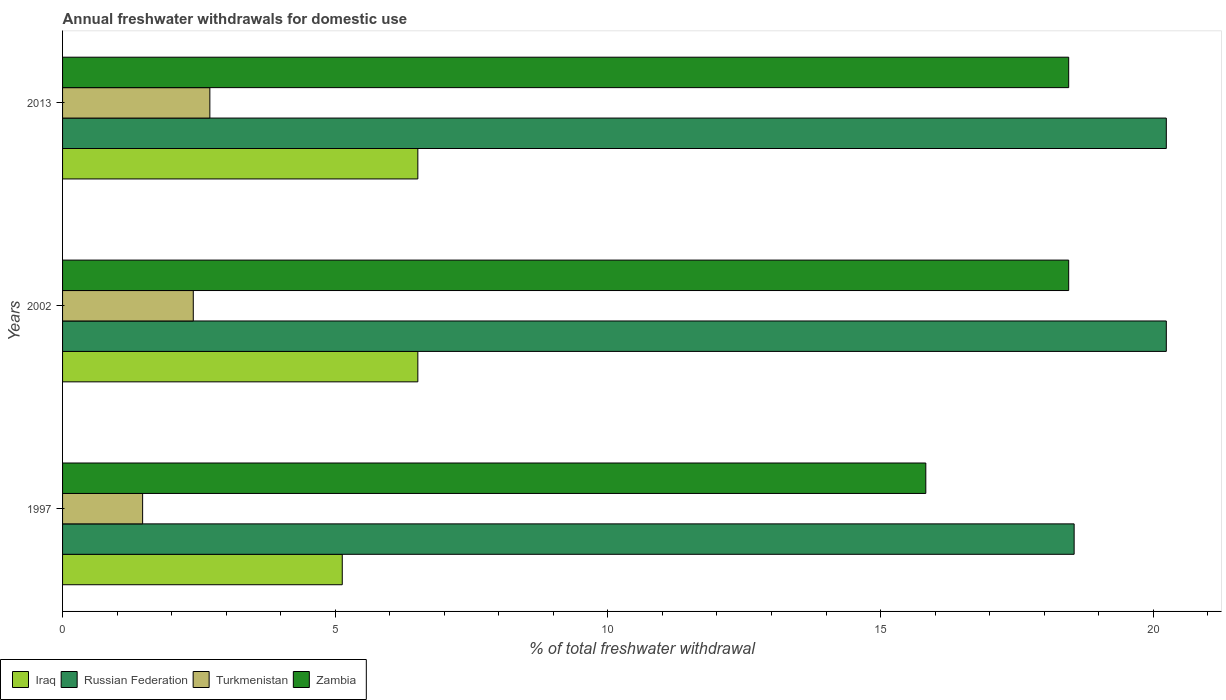How many groups of bars are there?
Keep it short and to the point. 3. Are the number of bars on each tick of the Y-axis equal?
Keep it short and to the point. Yes. How many bars are there on the 3rd tick from the top?
Ensure brevity in your answer.  4. What is the total annual withdrawals from freshwater in Russian Federation in 2002?
Provide a succinct answer. 20.24. Across all years, what is the maximum total annual withdrawals from freshwater in Russian Federation?
Provide a short and direct response. 20.24. Across all years, what is the minimum total annual withdrawals from freshwater in Russian Federation?
Your response must be concise. 18.55. What is the total total annual withdrawals from freshwater in Russian Federation in the graph?
Your response must be concise. 59.03. What is the difference between the total annual withdrawals from freshwater in Russian Federation in 1997 and that in 2013?
Give a very brief answer. -1.69. What is the difference between the total annual withdrawals from freshwater in Iraq in 2013 and the total annual withdrawals from freshwater in Russian Federation in 2002?
Give a very brief answer. -13.72. What is the average total annual withdrawals from freshwater in Iraq per year?
Give a very brief answer. 6.05. In the year 1997, what is the difference between the total annual withdrawals from freshwater in Zambia and total annual withdrawals from freshwater in Russian Federation?
Give a very brief answer. -2.72. In how many years, is the total annual withdrawals from freshwater in Zambia greater than 15 %?
Offer a terse response. 3. What is the ratio of the total annual withdrawals from freshwater in Turkmenistan in 1997 to that in 2013?
Provide a succinct answer. 0.54. Is the total annual withdrawals from freshwater in Zambia in 2002 less than that in 2013?
Your response must be concise. No. Is the difference between the total annual withdrawals from freshwater in Zambia in 1997 and 2002 greater than the difference between the total annual withdrawals from freshwater in Russian Federation in 1997 and 2002?
Your answer should be very brief. No. What is the difference between the highest and the second highest total annual withdrawals from freshwater in Iraq?
Offer a very short reply. 0. What is the difference between the highest and the lowest total annual withdrawals from freshwater in Turkmenistan?
Keep it short and to the point. 1.23. In how many years, is the total annual withdrawals from freshwater in Russian Federation greater than the average total annual withdrawals from freshwater in Russian Federation taken over all years?
Make the answer very short. 2. Is it the case that in every year, the sum of the total annual withdrawals from freshwater in Iraq and total annual withdrawals from freshwater in Turkmenistan is greater than the sum of total annual withdrawals from freshwater in Zambia and total annual withdrawals from freshwater in Russian Federation?
Make the answer very short. No. What does the 3rd bar from the top in 2002 represents?
Ensure brevity in your answer.  Russian Federation. What does the 2nd bar from the bottom in 2002 represents?
Make the answer very short. Russian Federation. What is the difference between two consecutive major ticks on the X-axis?
Your response must be concise. 5. Are the values on the major ticks of X-axis written in scientific E-notation?
Offer a terse response. No. Does the graph contain grids?
Ensure brevity in your answer.  No. Where does the legend appear in the graph?
Offer a very short reply. Bottom left. How are the legend labels stacked?
Ensure brevity in your answer.  Horizontal. What is the title of the graph?
Offer a terse response. Annual freshwater withdrawals for domestic use. What is the label or title of the X-axis?
Your answer should be compact. % of total freshwater withdrawal. What is the label or title of the Y-axis?
Offer a terse response. Years. What is the % of total freshwater withdrawal of Iraq in 1997?
Your answer should be compact. 5.13. What is the % of total freshwater withdrawal of Russian Federation in 1997?
Make the answer very short. 18.55. What is the % of total freshwater withdrawal in Turkmenistan in 1997?
Give a very brief answer. 1.47. What is the % of total freshwater withdrawal in Zambia in 1997?
Your answer should be very brief. 15.83. What is the % of total freshwater withdrawal of Iraq in 2002?
Provide a succinct answer. 6.51. What is the % of total freshwater withdrawal in Russian Federation in 2002?
Offer a very short reply. 20.24. What is the % of total freshwater withdrawal in Turkmenistan in 2002?
Offer a very short reply. 2.4. What is the % of total freshwater withdrawal of Zambia in 2002?
Offer a very short reply. 18.45. What is the % of total freshwater withdrawal in Iraq in 2013?
Offer a very short reply. 6.51. What is the % of total freshwater withdrawal of Russian Federation in 2013?
Give a very brief answer. 20.24. What is the % of total freshwater withdrawal in Turkmenistan in 2013?
Keep it short and to the point. 2.7. What is the % of total freshwater withdrawal in Zambia in 2013?
Your answer should be very brief. 18.45. Across all years, what is the maximum % of total freshwater withdrawal of Iraq?
Keep it short and to the point. 6.51. Across all years, what is the maximum % of total freshwater withdrawal in Russian Federation?
Your answer should be compact. 20.24. Across all years, what is the maximum % of total freshwater withdrawal of Turkmenistan?
Your response must be concise. 2.7. Across all years, what is the maximum % of total freshwater withdrawal in Zambia?
Your answer should be compact. 18.45. Across all years, what is the minimum % of total freshwater withdrawal of Iraq?
Give a very brief answer. 5.13. Across all years, what is the minimum % of total freshwater withdrawal of Russian Federation?
Provide a succinct answer. 18.55. Across all years, what is the minimum % of total freshwater withdrawal in Turkmenistan?
Ensure brevity in your answer.  1.47. Across all years, what is the minimum % of total freshwater withdrawal of Zambia?
Offer a very short reply. 15.83. What is the total % of total freshwater withdrawal in Iraq in the graph?
Offer a terse response. 18.16. What is the total % of total freshwater withdrawal of Russian Federation in the graph?
Your answer should be very brief. 59.03. What is the total % of total freshwater withdrawal in Turkmenistan in the graph?
Make the answer very short. 6.57. What is the total % of total freshwater withdrawal in Zambia in the graph?
Provide a succinct answer. 52.73. What is the difference between the % of total freshwater withdrawal of Iraq in 1997 and that in 2002?
Your response must be concise. -1.39. What is the difference between the % of total freshwater withdrawal of Russian Federation in 1997 and that in 2002?
Provide a short and direct response. -1.69. What is the difference between the % of total freshwater withdrawal in Turkmenistan in 1997 and that in 2002?
Give a very brief answer. -0.93. What is the difference between the % of total freshwater withdrawal in Zambia in 1997 and that in 2002?
Offer a terse response. -2.62. What is the difference between the % of total freshwater withdrawal in Iraq in 1997 and that in 2013?
Ensure brevity in your answer.  -1.39. What is the difference between the % of total freshwater withdrawal in Russian Federation in 1997 and that in 2013?
Offer a very short reply. -1.69. What is the difference between the % of total freshwater withdrawal of Turkmenistan in 1997 and that in 2013?
Your response must be concise. -1.23. What is the difference between the % of total freshwater withdrawal of Zambia in 1997 and that in 2013?
Your response must be concise. -2.62. What is the difference between the % of total freshwater withdrawal of Turkmenistan in 2002 and that in 2013?
Offer a terse response. -0.3. What is the difference between the % of total freshwater withdrawal in Zambia in 2002 and that in 2013?
Ensure brevity in your answer.  0. What is the difference between the % of total freshwater withdrawal in Iraq in 1997 and the % of total freshwater withdrawal in Russian Federation in 2002?
Offer a terse response. -15.11. What is the difference between the % of total freshwater withdrawal of Iraq in 1997 and the % of total freshwater withdrawal of Turkmenistan in 2002?
Keep it short and to the point. 2.73. What is the difference between the % of total freshwater withdrawal of Iraq in 1997 and the % of total freshwater withdrawal of Zambia in 2002?
Offer a terse response. -13.32. What is the difference between the % of total freshwater withdrawal in Russian Federation in 1997 and the % of total freshwater withdrawal in Turkmenistan in 2002?
Provide a short and direct response. 16.15. What is the difference between the % of total freshwater withdrawal of Turkmenistan in 1997 and the % of total freshwater withdrawal of Zambia in 2002?
Offer a very short reply. -16.98. What is the difference between the % of total freshwater withdrawal in Iraq in 1997 and the % of total freshwater withdrawal in Russian Federation in 2013?
Your response must be concise. -15.11. What is the difference between the % of total freshwater withdrawal of Iraq in 1997 and the % of total freshwater withdrawal of Turkmenistan in 2013?
Ensure brevity in your answer.  2.43. What is the difference between the % of total freshwater withdrawal of Iraq in 1997 and the % of total freshwater withdrawal of Zambia in 2013?
Your answer should be compact. -13.32. What is the difference between the % of total freshwater withdrawal of Russian Federation in 1997 and the % of total freshwater withdrawal of Turkmenistan in 2013?
Your answer should be compact. 15.85. What is the difference between the % of total freshwater withdrawal of Russian Federation in 1997 and the % of total freshwater withdrawal of Zambia in 2013?
Keep it short and to the point. 0.1. What is the difference between the % of total freshwater withdrawal in Turkmenistan in 1997 and the % of total freshwater withdrawal in Zambia in 2013?
Your answer should be very brief. -16.98. What is the difference between the % of total freshwater withdrawal of Iraq in 2002 and the % of total freshwater withdrawal of Russian Federation in 2013?
Give a very brief answer. -13.72. What is the difference between the % of total freshwater withdrawal in Iraq in 2002 and the % of total freshwater withdrawal in Turkmenistan in 2013?
Your answer should be compact. 3.81. What is the difference between the % of total freshwater withdrawal of Iraq in 2002 and the % of total freshwater withdrawal of Zambia in 2013?
Ensure brevity in your answer.  -11.94. What is the difference between the % of total freshwater withdrawal of Russian Federation in 2002 and the % of total freshwater withdrawal of Turkmenistan in 2013?
Ensure brevity in your answer.  17.54. What is the difference between the % of total freshwater withdrawal of Russian Federation in 2002 and the % of total freshwater withdrawal of Zambia in 2013?
Give a very brief answer. 1.79. What is the difference between the % of total freshwater withdrawal of Turkmenistan in 2002 and the % of total freshwater withdrawal of Zambia in 2013?
Offer a terse response. -16.05. What is the average % of total freshwater withdrawal of Iraq per year?
Provide a succinct answer. 6.05. What is the average % of total freshwater withdrawal in Russian Federation per year?
Your answer should be compact. 19.68. What is the average % of total freshwater withdrawal in Turkmenistan per year?
Provide a succinct answer. 2.19. What is the average % of total freshwater withdrawal of Zambia per year?
Ensure brevity in your answer.  17.58. In the year 1997, what is the difference between the % of total freshwater withdrawal of Iraq and % of total freshwater withdrawal of Russian Federation?
Your answer should be compact. -13.42. In the year 1997, what is the difference between the % of total freshwater withdrawal of Iraq and % of total freshwater withdrawal of Turkmenistan?
Provide a short and direct response. 3.66. In the year 1997, what is the difference between the % of total freshwater withdrawal of Iraq and % of total freshwater withdrawal of Zambia?
Your response must be concise. -10.7. In the year 1997, what is the difference between the % of total freshwater withdrawal of Russian Federation and % of total freshwater withdrawal of Turkmenistan?
Keep it short and to the point. 17.08. In the year 1997, what is the difference between the % of total freshwater withdrawal of Russian Federation and % of total freshwater withdrawal of Zambia?
Offer a terse response. 2.72. In the year 1997, what is the difference between the % of total freshwater withdrawal in Turkmenistan and % of total freshwater withdrawal in Zambia?
Your answer should be very brief. -14.36. In the year 2002, what is the difference between the % of total freshwater withdrawal of Iraq and % of total freshwater withdrawal of Russian Federation?
Provide a succinct answer. -13.72. In the year 2002, what is the difference between the % of total freshwater withdrawal in Iraq and % of total freshwater withdrawal in Turkmenistan?
Give a very brief answer. 4.12. In the year 2002, what is the difference between the % of total freshwater withdrawal in Iraq and % of total freshwater withdrawal in Zambia?
Ensure brevity in your answer.  -11.94. In the year 2002, what is the difference between the % of total freshwater withdrawal of Russian Federation and % of total freshwater withdrawal of Turkmenistan?
Offer a terse response. 17.84. In the year 2002, what is the difference between the % of total freshwater withdrawal in Russian Federation and % of total freshwater withdrawal in Zambia?
Give a very brief answer. 1.79. In the year 2002, what is the difference between the % of total freshwater withdrawal in Turkmenistan and % of total freshwater withdrawal in Zambia?
Your answer should be very brief. -16.05. In the year 2013, what is the difference between the % of total freshwater withdrawal of Iraq and % of total freshwater withdrawal of Russian Federation?
Offer a terse response. -13.72. In the year 2013, what is the difference between the % of total freshwater withdrawal of Iraq and % of total freshwater withdrawal of Turkmenistan?
Keep it short and to the point. 3.81. In the year 2013, what is the difference between the % of total freshwater withdrawal in Iraq and % of total freshwater withdrawal in Zambia?
Offer a very short reply. -11.94. In the year 2013, what is the difference between the % of total freshwater withdrawal in Russian Federation and % of total freshwater withdrawal in Turkmenistan?
Your response must be concise. 17.54. In the year 2013, what is the difference between the % of total freshwater withdrawal in Russian Federation and % of total freshwater withdrawal in Zambia?
Provide a succinct answer. 1.79. In the year 2013, what is the difference between the % of total freshwater withdrawal in Turkmenistan and % of total freshwater withdrawal in Zambia?
Make the answer very short. -15.75. What is the ratio of the % of total freshwater withdrawal in Iraq in 1997 to that in 2002?
Give a very brief answer. 0.79. What is the ratio of the % of total freshwater withdrawal of Russian Federation in 1997 to that in 2002?
Provide a succinct answer. 0.92. What is the ratio of the % of total freshwater withdrawal in Turkmenistan in 1997 to that in 2002?
Provide a short and direct response. 0.61. What is the ratio of the % of total freshwater withdrawal of Zambia in 1997 to that in 2002?
Keep it short and to the point. 0.86. What is the ratio of the % of total freshwater withdrawal in Iraq in 1997 to that in 2013?
Offer a very short reply. 0.79. What is the ratio of the % of total freshwater withdrawal of Russian Federation in 1997 to that in 2013?
Your response must be concise. 0.92. What is the ratio of the % of total freshwater withdrawal of Turkmenistan in 1997 to that in 2013?
Offer a terse response. 0.54. What is the ratio of the % of total freshwater withdrawal in Zambia in 1997 to that in 2013?
Your answer should be compact. 0.86. What is the ratio of the % of total freshwater withdrawal in Turkmenistan in 2002 to that in 2013?
Your answer should be very brief. 0.89. What is the difference between the highest and the second highest % of total freshwater withdrawal in Turkmenistan?
Give a very brief answer. 0.3. What is the difference between the highest and the second highest % of total freshwater withdrawal in Zambia?
Provide a short and direct response. 0. What is the difference between the highest and the lowest % of total freshwater withdrawal of Iraq?
Offer a very short reply. 1.39. What is the difference between the highest and the lowest % of total freshwater withdrawal in Russian Federation?
Your answer should be compact. 1.69. What is the difference between the highest and the lowest % of total freshwater withdrawal in Turkmenistan?
Your response must be concise. 1.23. What is the difference between the highest and the lowest % of total freshwater withdrawal in Zambia?
Make the answer very short. 2.62. 